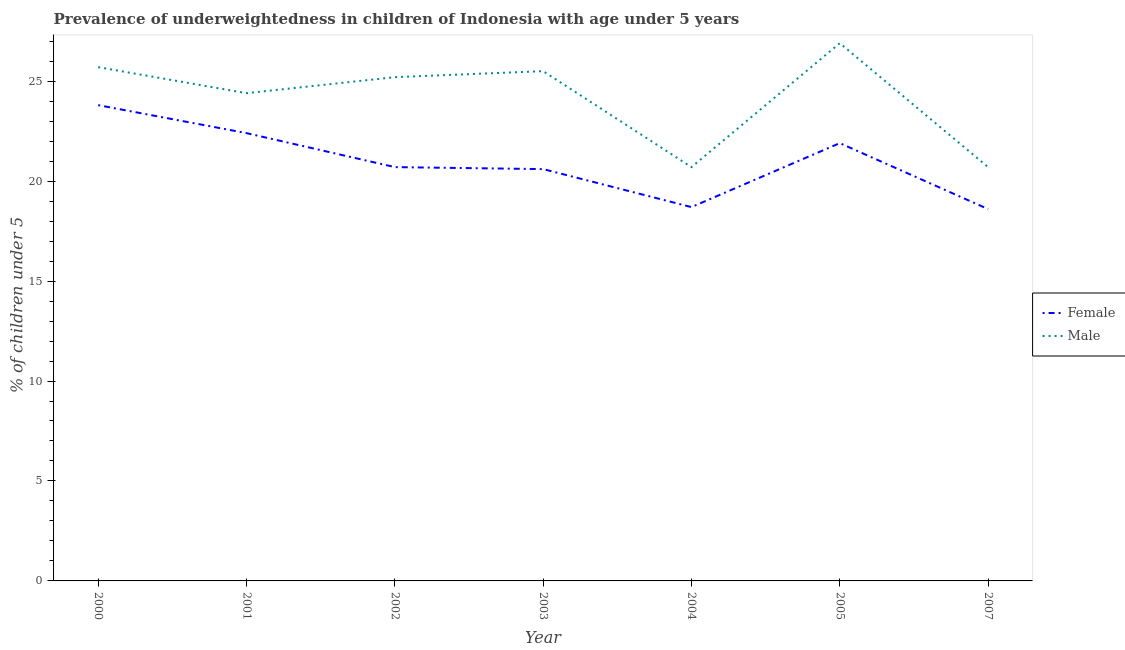Does the line corresponding to percentage of underweighted female children intersect with the line corresponding to percentage of underweighted male children?
Offer a terse response. No. Is the number of lines equal to the number of legend labels?
Offer a very short reply. Yes. What is the percentage of underweighted male children in 2004?
Provide a short and direct response. 20.7. Across all years, what is the maximum percentage of underweighted female children?
Provide a succinct answer. 23.8. Across all years, what is the minimum percentage of underweighted male children?
Provide a succinct answer. 20.7. In which year was the percentage of underweighted female children minimum?
Your answer should be compact. 2007. What is the total percentage of underweighted male children in the graph?
Your answer should be compact. 169.1. What is the difference between the percentage of underweighted female children in 2000 and that in 2003?
Your answer should be very brief. 3.2. What is the difference between the percentage of underweighted female children in 2007 and the percentage of underweighted male children in 2000?
Ensure brevity in your answer.  -7.1. What is the average percentage of underweighted male children per year?
Your answer should be very brief. 24.16. In how many years, is the percentage of underweighted female children greater than 24 %?
Your response must be concise. 0. What is the ratio of the percentage of underweighted female children in 2000 to that in 2001?
Your response must be concise. 1.06. Is the difference between the percentage of underweighted female children in 2000 and 2002 greater than the difference between the percentage of underweighted male children in 2000 and 2002?
Provide a succinct answer. Yes. What is the difference between the highest and the second highest percentage of underweighted female children?
Offer a terse response. 1.4. What is the difference between the highest and the lowest percentage of underweighted female children?
Offer a very short reply. 5.2. Is the sum of the percentage of underweighted male children in 2002 and 2007 greater than the maximum percentage of underweighted female children across all years?
Make the answer very short. Yes. Does the percentage of underweighted female children monotonically increase over the years?
Your answer should be very brief. No. Is the percentage of underweighted male children strictly less than the percentage of underweighted female children over the years?
Offer a terse response. No. How many lines are there?
Offer a terse response. 2. How many years are there in the graph?
Ensure brevity in your answer.  7. What is the difference between two consecutive major ticks on the Y-axis?
Offer a terse response. 5. Does the graph contain any zero values?
Your answer should be compact. No. Does the graph contain grids?
Your answer should be very brief. No. Where does the legend appear in the graph?
Your response must be concise. Center right. What is the title of the graph?
Your answer should be compact. Prevalence of underweightedness in children of Indonesia with age under 5 years. What is the label or title of the X-axis?
Ensure brevity in your answer.  Year. What is the label or title of the Y-axis?
Provide a succinct answer.  % of children under 5. What is the  % of children under 5 in Female in 2000?
Make the answer very short. 23.8. What is the  % of children under 5 in Male in 2000?
Your response must be concise. 25.7. What is the  % of children under 5 of Female in 2001?
Your answer should be compact. 22.4. What is the  % of children under 5 in Male in 2001?
Give a very brief answer. 24.4. What is the  % of children under 5 of Female in 2002?
Your answer should be very brief. 20.7. What is the  % of children under 5 in Male in 2002?
Make the answer very short. 25.2. What is the  % of children under 5 of Female in 2003?
Your answer should be very brief. 20.6. What is the  % of children under 5 in Male in 2003?
Give a very brief answer. 25.5. What is the  % of children under 5 in Female in 2004?
Your response must be concise. 18.7. What is the  % of children under 5 of Male in 2004?
Ensure brevity in your answer.  20.7. What is the  % of children under 5 in Female in 2005?
Offer a terse response. 21.9. What is the  % of children under 5 of Male in 2005?
Provide a succinct answer. 26.9. What is the  % of children under 5 in Female in 2007?
Your answer should be compact. 18.6. What is the  % of children under 5 of Male in 2007?
Give a very brief answer. 20.7. Across all years, what is the maximum  % of children under 5 of Female?
Ensure brevity in your answer.  23.8. Across all years, what is the maximum  % of children under 5 in Male?
Your response must be concise. 26.9. Across all years, what is the minimum  % of children under 5 in Female?
Keep it short and to the point. 18.6. Across all years, what is the minimum  % of children under 5 of Male?
Your response must be concise. 20.7. What is the total  % of children under 5 in Female in the graph?
Make the answer very short. 146.7. What is the total  % of children under 5 of Male in the graph?
Make the answer very short. 169.1. What is the difference between the  % of children under 5 in Male in 2000 and that in 2001?
Offer a very short reply. 1.3. What is the difference between the  % of children under 5 of Female in 2000 and that in 2004?
Keep it short and to the point. 5.1. What is the difference between the  % of children under 5 in Female in 2000 and that in 2005?
Your response must be concise. 1.9. What is the difference between the  % of children under 5 in Female in 2000 and that in 2007?
Your answer should be compact. 5.2. What is the difference between the  % of children under 5 of Male in 2000 and that in 2007?
Ensure brevity in your answer.  5. What is the difference between the  % of children under 5 of Male in 2001 and that in 2002?
Keep it short and to the point. -0.8. What is the difference between the  % of children under 5 of Male in 2001 and that in 2003?
Provide a short and direct response. -1.1. What is the difference between the  % of children under 5 of Male in 2002 and that in 2003?
Your response must be concise. -0.3. What is the difference between the  % of children under 5 in Female in 2002 and that in 2004?
Give a very brief answer. 2. What is the difference between the  % of children under 5 of Male in 2002 and that in 2004?
Provide a short and direct response. 4.5. What is the difference between the  % of children under 5 in Male in 2002 and that in 2005?
Make the answer very short. -1.7. What is the difference between the  % of children under 5 in Male in 2002 and that in 2007?
Offer a very short reply. 4.5. What is the difference between the  % of children under 5 in Male in 2003 and that in 2004?
Keep it short and to the point. 4.8. What is the difference between the  % of children under 5 of Female in 2003 and that in 2005?
Keep it short and to the point. -1.3. What is the difference between the  % of children under 5 in Male in 2003 and that in 2005?
Your answer should be compact. -1.4. What is the difference between the  % of children under 5 in Female in 2003 and that in 2007?
Offer a very short reply. 2. What is the difference between the  % of children under 5 in Female in 2004 and that in 2005?
Your answer should be very brief. -3.2. What is the difference between the  % of children under 5 in Male in 2004 and that in 2007?
Offer a terse response. 0. What is the difference between the  % of children under 5 of Female in 2005 and that in 2007?
Offer a terse response. 3.3. What is the difference between the  % of children under 5 of Male in 2005 and that in 2007?
Provide a succinct answer. 6.2. What is the difference between the  % of children under 5 in Female in 2000 and the  % of children under 5 in Male in 2002?
Your response must be concise. -1.4. What is the difference between the  % of children under 5 in Female in 2000 and the  % of children under 5 in Male in 2004?
Give a very brief answer. 3.1. What is the difference between the  % of children under 5 in Female in 2000 and the  % of children under 5 in Male in 2005?
Your answer should be very brief. -3.1. What is the difference between the  % of children under 5 of Female in 2000 and the  % of children under 5 of Male in 2007?
Your response must be concise. 3.1. What is the difference between the  % of children under 5 of Female in 2001 and the  % of children under 5 of Male in 2002?
Your answer should be compact. -2.8. What is the difference between the  % of children under 5 of Female in 2001 and the  % of children under 5 of Male in 2003?
Your answer should be compact. -3.1. What is the difference between the  % of children under 5 in Female in 2001 and the  % of children under 5 in Male in 2004?
Your response must be concise. 1.7. What is the difference between the  % of children under 5 in Female in 2002 and the  % of children under 5 in Male in 2003?
Provide a short and direct response. -4.8. What is the difference between the  % of children under 5 of Female in 2002 and the  % of children under 5 of Male in 2005?
Give a very brief answer. -6.2. What is the difference between the  % of children under 5 in Female in 2002 and the  % of children under 5 in Male in 2007?
Your answer should be compact. 0. What is the difference between the  % of children under 5 of Female in 2003 and the  % of children under 5 of Male in 2004?
Ensure brevity in your answer.  -0.1. What is the difference between the  % of children under 5 of Female in 2003 and the  % of children under 5 of Male in 2005?
Offer a very short reply. -6.3. What is the difference between the  % of children under 5 of Female in 2003 and the  % of children under 5 of Male in 2007?
Provide a succinct answer. -0.1. What is the difference between the  % of children under 5 in Female in 2005 and the  % of children under 5 in Male in 2007?
Make the answer very short. 1.2. What is the average  % of children under 5 of Female per year?
Give a very brief answer. 20.96. What is the average  % of children under 5 of Male per year?
Offer a very short reply. 24.16. In the year 2002, what is the difference between the  % of children under 5 in Female and  % of children under 5 in Male?
Offer a very short reply. -4.5. In the year 2005, what is the difference between the  % of children under 5 of Female and  % of children under 5 of Male?
Offer a very short reply. -5. What is the ratio of the  % of children under 5 of Male in 2000 to that in 2001?
Offer a terse response. 1.05. What is the ratio of the  % of children under 5 in Female in 2000 to that in 2002?
Give a very brief answer. 1.15. What is the ratio of the  % of children under 5 of Male in 2000 to that in 2002?
Ensure brevity in your answer.  1.02. What is the ratio of the  % of children under 5 of Female in 2000 to that in 2003?
Your response must be concise. 1.16. What is the ratio of the  % of children under 5 of Male in 2000 to that in 2003?
Keep it short and to the point. 1.01. What is the ratio of the  % of children under 5 in Female in 2000 to that in 2004?
Provide a short and direct response. 1.27. What is the ratio of the  % of children under 5 in Male in 2000 to that in 2004?
Your answer should be compact. 1.24. What is the ratio of the  % of children under 5 in Female in 2000 to that in 2005?
Offer a very short reply. 1.09. What is the ratio of the  % of children under 5 of Male in 2000 to that in 2005?
Make the answer very short. 0.96. What is the ratio of the  % of children under 5 of Female in 2000 to that in 2007?
Your response must be concise. 1.28. What is the ratio of the  % of children under 5 of Male in 2000 to that in 2007?
Ensure brevity in your answer.  1.24. What is the ratio of the  % of children under 5 in Female in 2001 to that in 2002?
Provide a succinct answer. 1.08. What is the ratio of the  % of children under 5 of Male in 2001 to that in 2002?
Ensure brevity in your answer.  0.97. What is the ratio of the  % of children under 5 of Female in 2001 to that in 2003?
Make the answer very short. 1.09. What is the ratio of the  % of children under 5 of Male in 2001 to that in 2003?
Your answer should be compact. 0.96. What is the ratio of the  % of children under 5 in Female in 2001 to that in 2004?
Provide a succinct answer. 1.2. What is the ratio of the  % of children under 5 of Male in 2001 to that in 2004?
Offer a very short reply. 1.18. What is the ratio of the  % of children under 5 in Female in 2001 to that in 2005?
Offer a very short reply. 1.02. What is the ratio of the  % of children under 5 in Male in 2001 to that in 2005?
Provide a succinct answer. 0.91. What is the ratio of the  % of children under 5 in Female in 2001 to that in 2007?
Your answer should be very brief. 1.2. What is the ratio of the  % of children under 5 of Male in 2001 to that in 2007?
Your answer should be compact. 1.18. What is the ratio of the  % of children under 5 in Male in 2002 to that in 2003?
Offer a terse response. 0.99. What is the ratio of the  % of children under 5 in Female in 2002 to that in 2004?
Your answer should be very brief. 1.11. What is the ratio of the  % of children under 5 in Male in 2002 to that in 2004?
Offer a terse response. 1.22. What is the ratio of the  % of children under 5 of Female in 2002 to that in 2005?
Keep it short and to the point. 0.95. What is the ratio of the  % of children under 5 of Male in 2002 to that in 2005?
Give a very brief answer. 0.94. What is the ratio of the  % of children under 5 of Female in 2002 to that in 2007?
Make the answer very short. 1.11. What is the ratio of the  % of children under 5 in Male in 2002 to that in 2007?
Provide a succinct answer. 1.22. What is the ratio of the  % of children under 5 in Female in 2003 to that in 2004?
Provide a succinct answer. 1.1. What is the ratio of the  % of children under 5 of Male in 2003 to that in 2004?
Keep it short and to the point. 1.23. What is the ratio of the  % of children under 5 of Female in 2003 to that in 2005?
Ensure brevity in your answer.  0.94. What is the ratio of the  % of children under 5 of Male in 2003 to that in 2005?
Provide a succinct answer. 0.95. What is the ratio of the  % of children under 5 in Female in 2003 to that in 2007?
Keep it short and to the point. 1.11. What is the ratio of the  % of children under 5 of Male in 2003 to that in 2007?
Your answer should be compact. 1.23. What is the ratio of the  % of children under 5 in Female in 2004 to that in 2005?
Offer a terse response. 0.85. What is the ratio of the  % of children under 5 of Male in 2004 to that in 2005?
Offer a very short reply. 0.77. What is the ratio of the  % of children under 5 in Female in 2004 to that in 2007?
Your response must be concise. 1.01. What is the ratio of the  % of children under 5 of Female in 2005 to that in 2007?
Make the answer very short. 1.18. What is the ratio of the  % of children under 5 in Male in 2005 to that in 2007?
Your answer should be very brief. 1.3. What is the difference between the highest and the second highest  % of children under 5 of Female?
Your answer should be compact. 1.4. What is the difference between the highest and the second highest  % of children under 5 of Male?
Provide a succinct answer. 1.2. What is the difference between the highest and the lowest  % of children under 5 in Female?
Give a very brief answer. 5.2. 